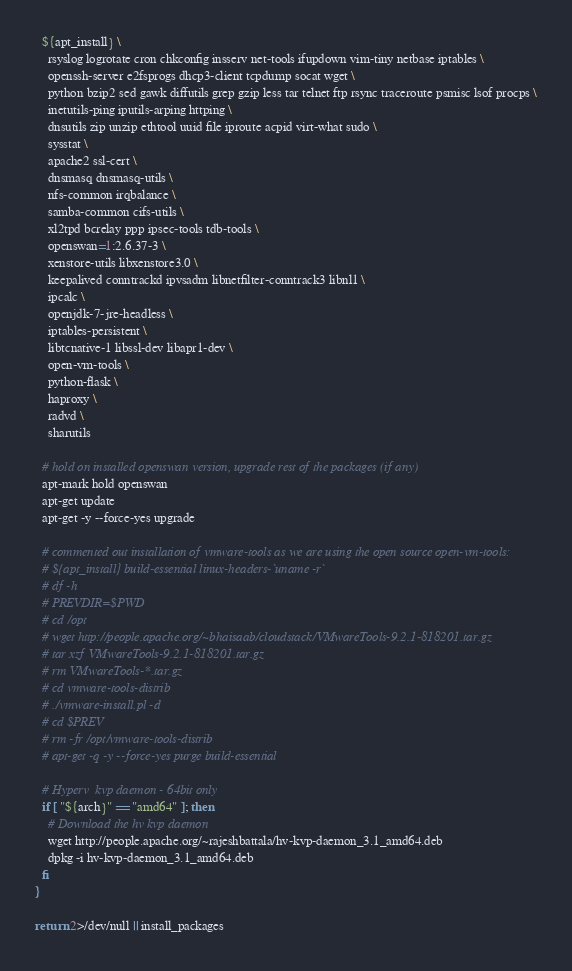<code> <loc_0><loc_0><loc_500><loc_500><_Bash_>  ${apt_install} \
    rsyslog logrotate cron chkconfig insserv net-tools ifupdown vim-tiny netbase iptables \
    openssh-server e2fsprogs dhcp3-client tcpdump socat wget \
    python bzip2 sed gawk diffutils grep gzip less tar telnet ftp rsync traceroute psmisc lsof procps \
    inetutils-ping iputils-arping httping \
    dnsutils zip unzip ethtool uuid file iproute acpid virt-what sudo \
    sysstat \
    apache2 ssl-cert \
    dnsmasq dnsmasq-utils \
    nfs-common irqbalance \
    samba-common cifs-utils \
    xl2tpd bcrelay ppp ipsec-tools tdb-tools \
    openswan=1:2.6.37-3 \
    xenstore-utils libxenstore3.0 \
    keepalived conntrackd ipvsadm libnetfilter-conntrack3 libnl1 \
    ipcalc \
    openjdk-7-jre-headless \
    iptables-persistent \
    libtcnative-1 libssl-dev libapr1-dev \
    open-vm-tools \
    python-flask \
    haproxy \
    radvd \
    sharutils

  # hold on installed openswan version, upgrade rest of the packages (if any)
  apt-mark hold openswan
  apt-get update
  apt-get -y --force-yes upgrade

  # commented out installation of vmware-tools as we are using the open source open-vm-tools:
  # ${apt_install} build-essential linux-headers-`uname -r`
  # df -h
  # PREVDIR=$PWD
  # cd /opt
  # wget http://people.apache.org/~bhaisaab/cloudstack/VMwareTools-9.2.1-818201.tar.gz
  # tar xzf VMwareTools-9.2.1-818201.tar.gz
  # rm VMwareTools-*.tar.gz
  # cd vmware-tools-distrib
  # ./vmware-install.pl -d
  # cd $PREV
  # rm -fr /opt/vmware-tools-distrib
  # apt-get -q -y --force-yes purge build-essential

  # Hyperv  kvp daemon - 64bit only
  if [ "${arch}" == "amd64" ]; then
    # Download the hv kvp daemon
    wget http://people.apache.org/~rajeshbattala/hv-kvp-daemon_3.1_amd64.deb
    dpkg -i hv-kvp-daemon_3.1_amd64.deb
  fi
}

return 2>/dev/null || install_packages
</code> 